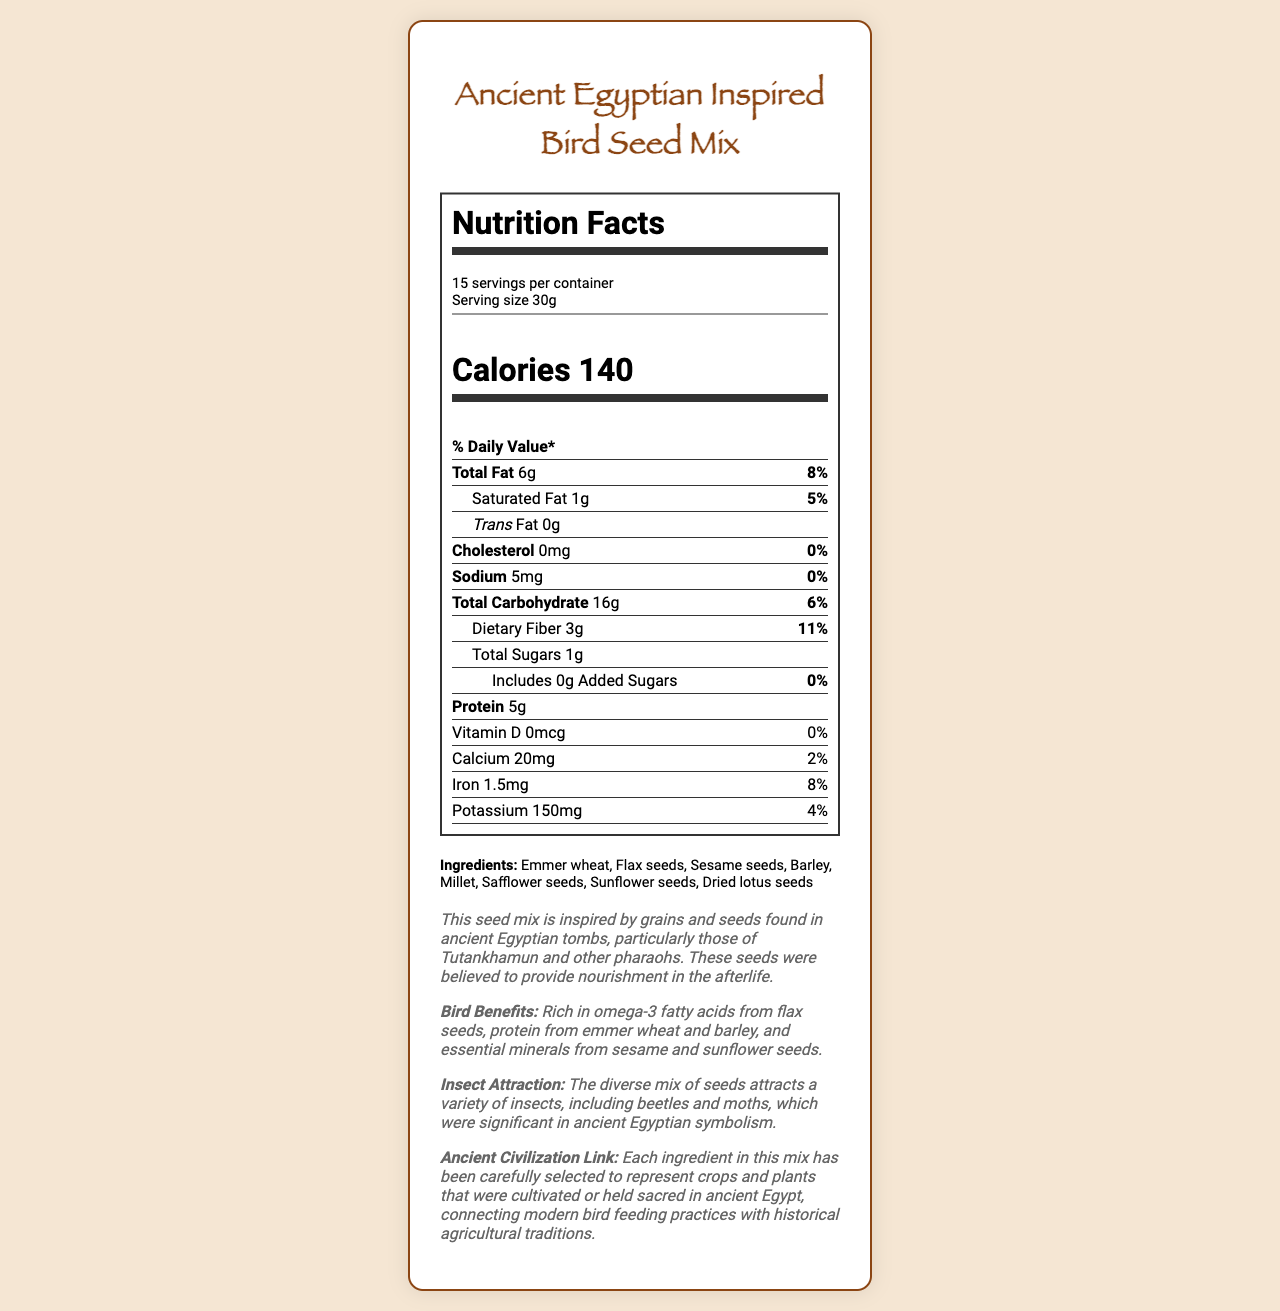what is the serving size? The serving size is listed under the nutrition facts as "Serving size 30g".
Answer: 30g how many calories are there per serving? The document states "Calories 140" under the nutrition facts.
Answer: 140 what is the total fat content per serving? The total fat per serving is listed as "Total Fat 6g" in the nutrient details.
Answer: 6g does the bird seed mix contain any cholesterol? The document indicates "Cholesterol 0mg" under the nutrient information.
Answer: No what is the historical context of this seed mix? The historical context is provided in the text section under "historical_context".
Answer: The seed mix is inspired by grains and seeds found in ancient Egyptian tombs, particularly those of Tutankhamun and other pharaohs. These seeds were believed to provide nourishment in the afterlife. how much protein is in one serving of bird seed mix? The document states "Protein 5g" in the nutrient details.
Answer: 5g what are the main benefits for birds eating this seed mix? The bird benefits section notes that the mix is rich in omega-3 fatty acids from flax seeds, protein from emmer wheat and barley, and essential minerals from sesame and sunflower seeds.
Answer: Rich in omega-3 fatty acids, protein, and essential minerals. which ingredient is not part of the bird seed mix? A. Emmer wheat B. Corn C. Flax seeds D. Barley Corn is not listed in the ingredients section, while the others are.
Answer: B how many servings are there in one container? A. 10 B. 12 C. 15 D. 18 The document states "15 servings per container".
Answer: C what is the dietary fiber content per serving? A. 1g B. 3g C. 5g D. 7g The dietary fiber content per serving is listed as "3g".
Answer: B is there any added sugar in this bird seed mix? The document mentions "Includes 0g Added Sugars" indicating there is no added sugar.
Answer: No are the seeds beneficial for attracting any specific insects? The insect attraction section states that the mix attracts a variety of insects, including beetles and moths, significant in ancient Egyptian symbolism.
Answer: Yes can the exact vitamin D source be identified from the document? The document only lists "Vitamin D 0mcg" with no source mentioned.
Answer: Cannot be determined summarize the main idea of the document. The document is focused on presenting the nutritional facts of the bird seed mix, which is historically inspired and beneficial for both birds and insects. The ingredients are selected to represent crops and plants significant in ancient Egypt.
Answer: The document provides a detailed nutritional breakdown of a bird seed mix inspired by seeds found in ancient Egyptian tombs, highlighting its historical context, benefits for birds, and insect attraction properties. Each serving is 30g with 140 calories and a mix of fats, proteins, and carbohydrates, along with various vitamins and minerals. how much calcium is in one serving? The document specifies "Calcium 20mg" under the nutrient details.
Answer: 20mg 